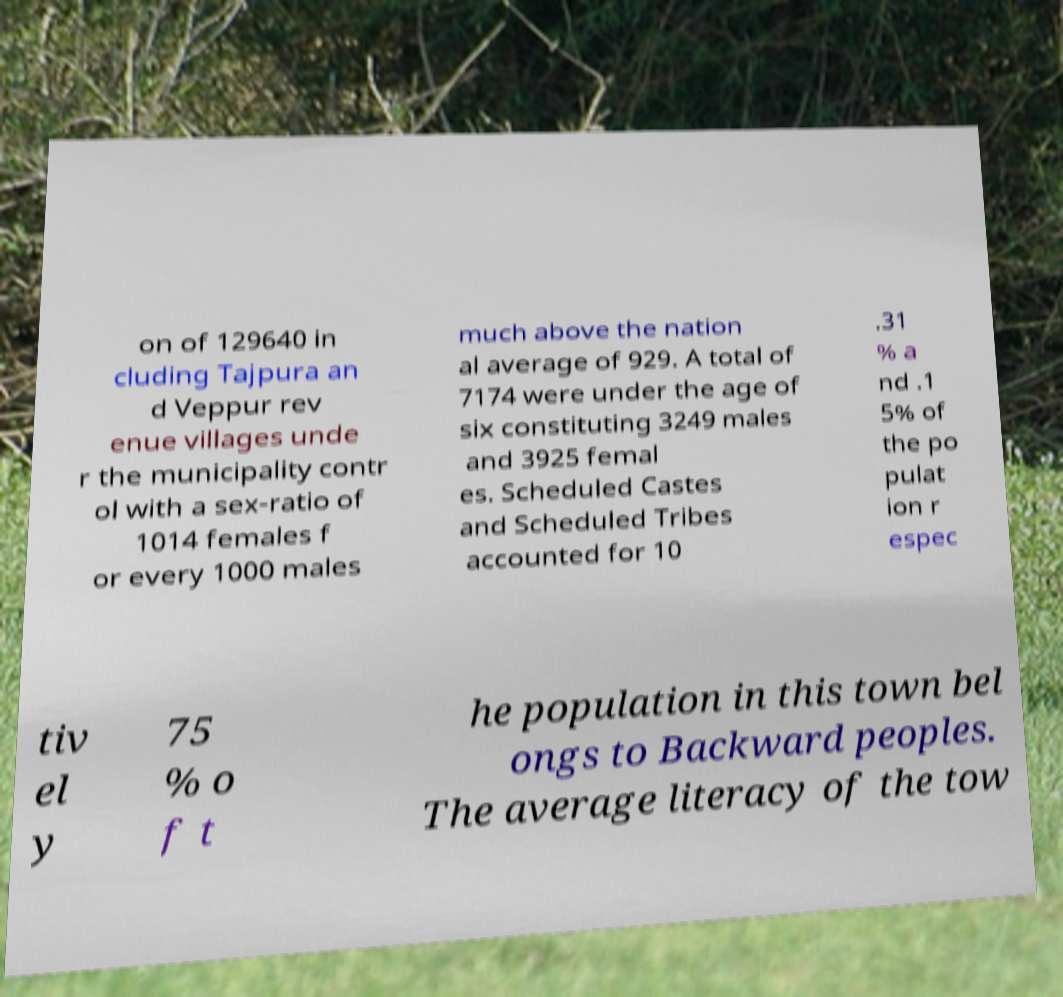Could you extract and type out the text from this image? on of 129640 in cluding Tajpura an d Veppur rev enue villages unde r the municipality contr ol with a sex-ratio of 1014 females f or every 1000 males much above the nation al average of 929. A total of 7174 were under the age of six constituting 3249 males and 3925 femal es. Scheduled Castes and Scheduled Tribes accounted for 10 .31 % a nd .1 5% of the po pulat ion r espec tiv el y 75 % o f t he population in this town bel ongs to Backward peoples. The average literacy of the tow 